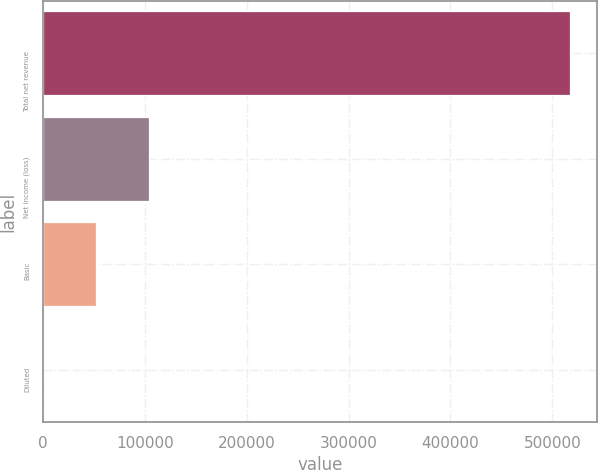Convert chart to OTSL. <chart><loc_0><loc_0><loc_500><loc_500><bar_chart><fcel>Total net revenue<fcel>Net income (loss)<fcel>Basic<fcel>Diluted<nl><fcel>517619<fcel>103524<fcel>51762<fcel>0.16<nl></chart> 